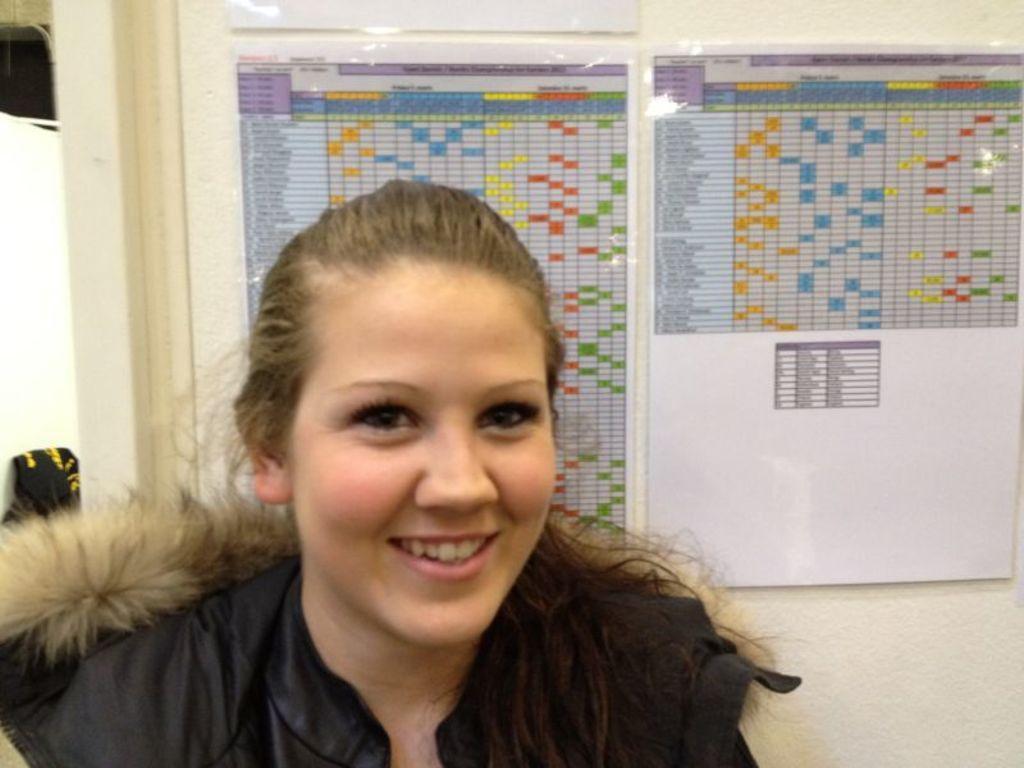Please provide a concise description of this image. In this image we can see a woman. On the backside we can see some papers pasted on a wall. 